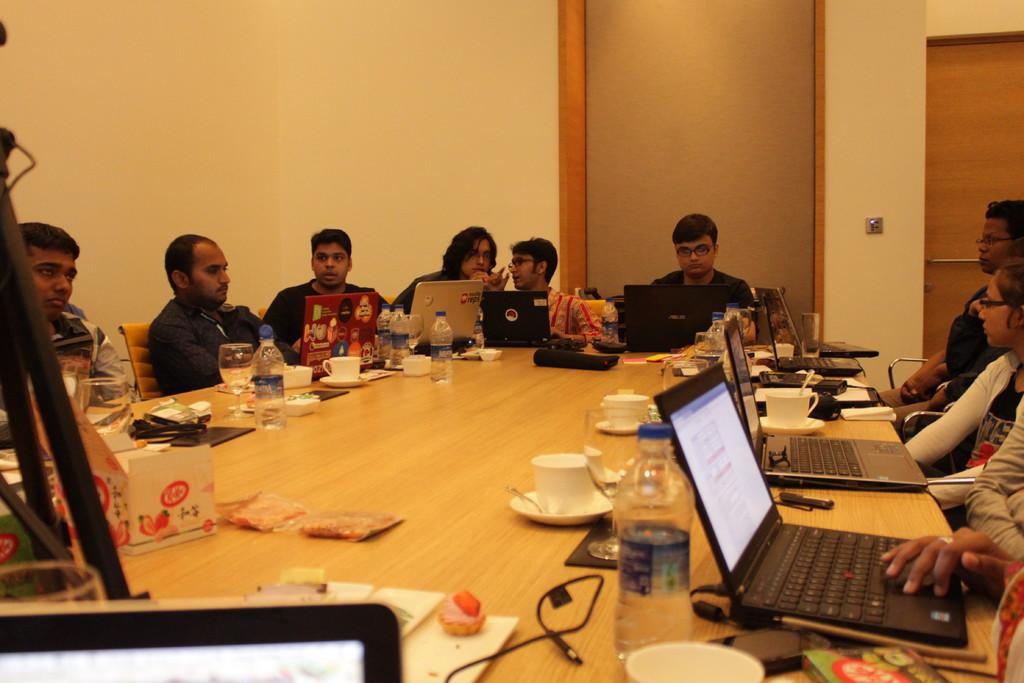What are the people in the image doing? People are sitting around a table in the image. What are the people sitting on? The people are sitting in chairs. What electronic devices can be seen on the table? There are laptops on the table. What beverages are present on the table? There are water bottles and glasses on the table. What type of drink might be served in the cups on the table? There are tea cups on the table, suggesting that tea might be served. Can you see a bird flying over the table in the image? There is no bird visible in the image. Is there a jar filled with cookies on the table? There is no jar or cookies mentioned in the provided facts about the image. 